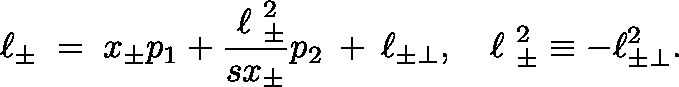<formula> <loc_0><loc_0><loc_500><loc_500>\ell _ { \pm } \, = \, x _ { \pm } p _ { 1 } + \frac { \boldmath \ell _ { \pm } ^ { 2 } } { s x _ { \pm } } p _ { 2 } \, + \, \ell _ { \pm \perp } , \, \boldmath \ell _ { \pm } ^ { 2 } \equiv - \ell _ { \pm \perp } ^ { 2 } .</formula> 